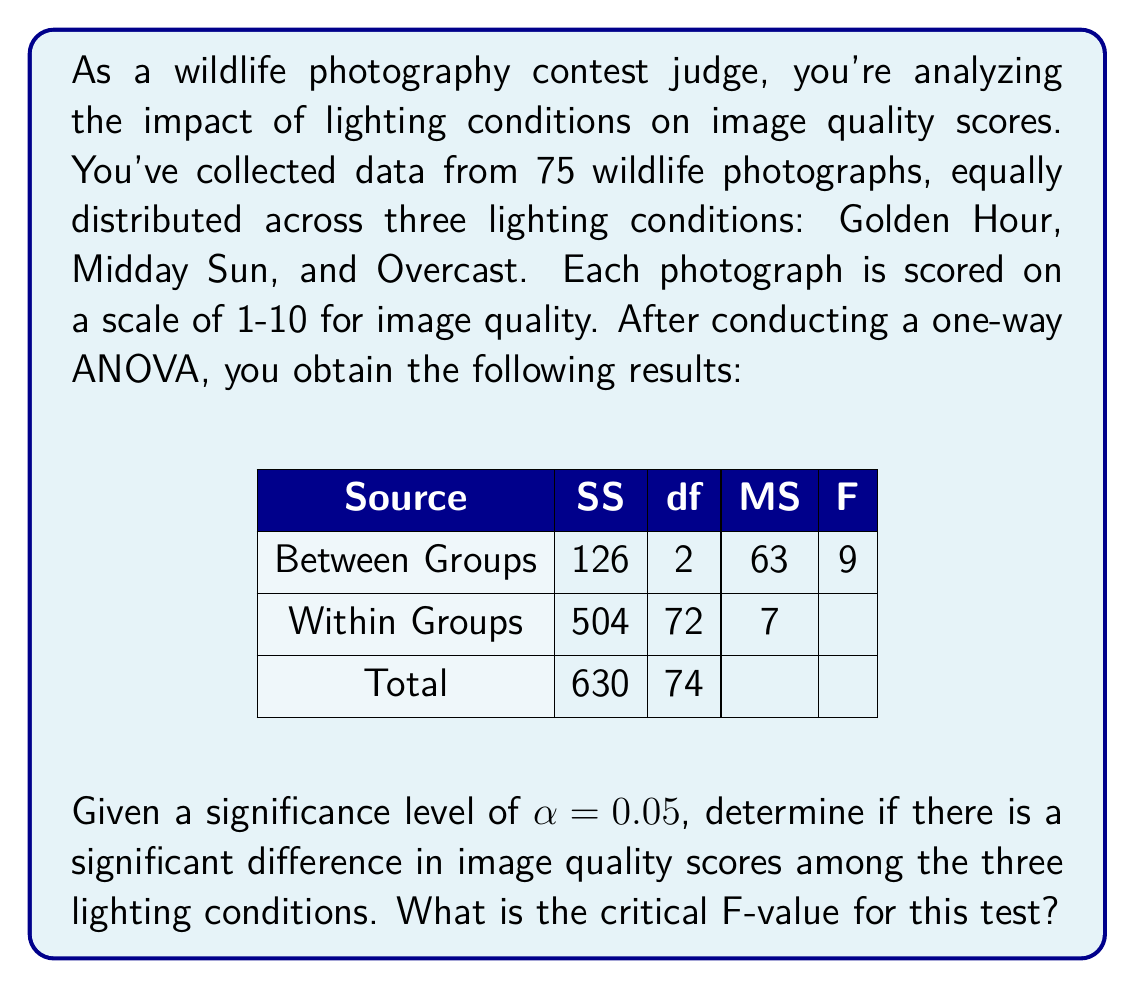Give your solution to this math problem. To determine if there is a significant difference in image quality scores among the three lighting conditions, we need to compare the calculated F-value with the critical F-value.

Step 1: Identify the degrees of freedom
- Numerator df (between groups) = 2
- Denominator df (within groups) = 72

Step 2: Determine the critical F-value
Using an F-distribution table or calculator with $\alpha = 0.05$, df1 = 2, and df2 = 72, we find:
$F_{critical} = 3.124$

Step 3: Compare the calculated F-value with the critical F-value
Calculated $F = 9$
Critical $F = 3.124$

Since the calculated F-value (9) is greater than the critical F-value (3.124), we reject the null hypothesis.

Step 4: Interpret the results
There is strong evidence to suggest that there is a significant difference in image quality scores among the three lighting conditions (Golden Hour, Midday Sun, and Overcast) at the 0.05 significance level.

This result indicates that as a wildlife photography contest judge, you can conclude that lighting conditions have a significant effect on the quality of wildlife photographs. This information can be valuable for photographers and for setting contest guidelines.
Answer: The critical F-value for this test is 3.124. There is a significant difference in image quality scores among the three lighting conditions at the 0.05 significance level. 